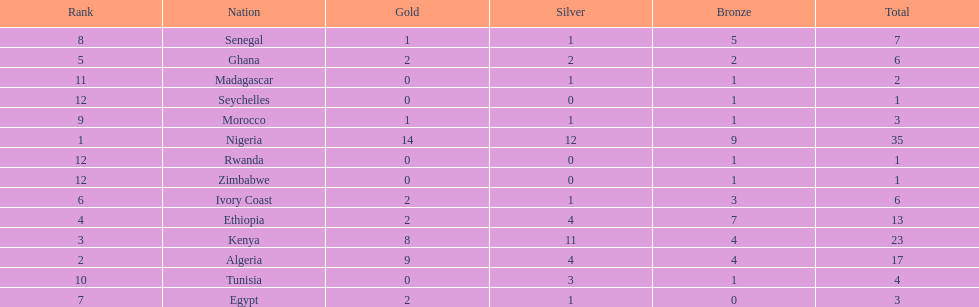The nation above algeria Nigeria. 